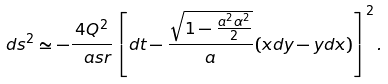Convert formula to latex. <formula><loc_0><loc_0><loc_500><loc_500>d s ^ { 2 } \simeq - \frac { 4 Q ^ { 2 } } { \ a s r } \left [ d t - \frac { \sqrt { 1 - \frac { a ^ { 2 } \alpha ^ { 2 } } { 2 } } } { a } ( x d y - y d x ) \right ] ^ { 2 } .</formula> 